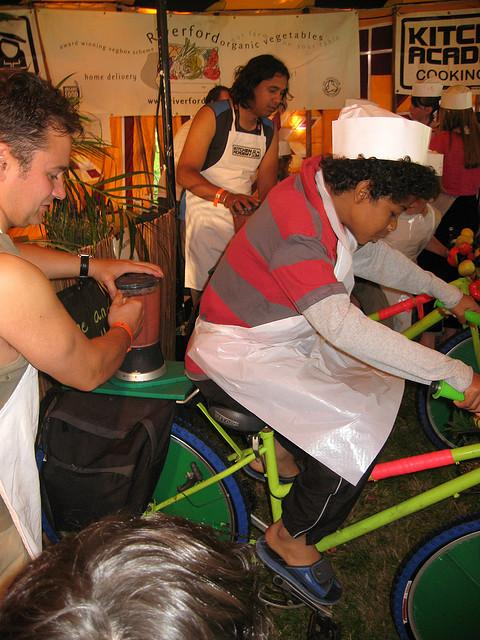What does the person in the white hat power? bike 